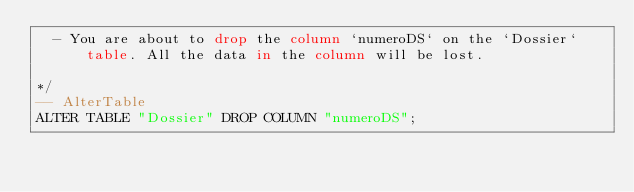Convert code to text. <code><loc_0><loc_0><loc_500><loc_500><_SQL_>  - You are about to drop the column `numeroDS` on the `Dossier` table. All the data in the column will be lost.

*/
-- AlterTable
ALTER TABLE "Dossier" DROP COLUMN "numeroDS";
</code> 